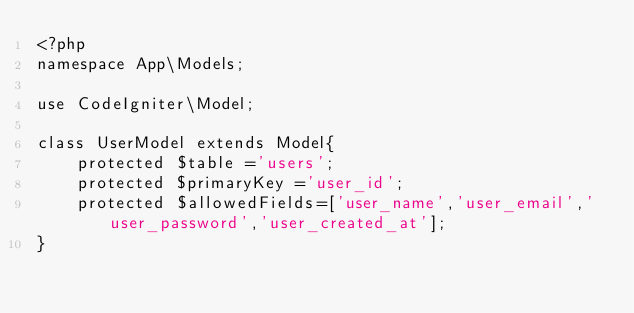<code> <loc_0><loc_0><loc_500><loc_500><_PHP_><?php
namespace App\Models;

use CodeIgniter\Model;

class UserModel extends Model{
    protected $table ='users';
    protected $primaryKey ='user_id';
    protected $allowedFields=['user_name','user_email','user_password','user_created_at'];
}</code> 